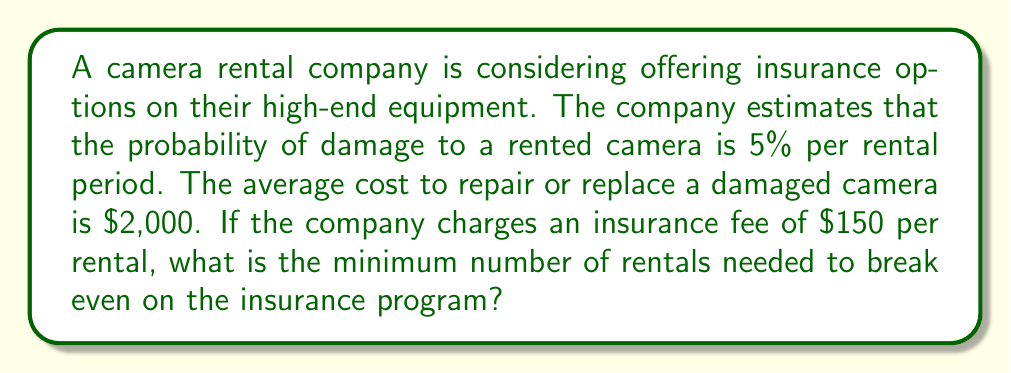Give your solution to this math problem. To solve this problem, we need to find the break-even point where the total revenue from insurance fees equals the expected cost of repairs. Let's approach this step-by-step:

1. Define variables:
   Let $n$ be the number of rentals
   Let $p$ be the probability of damage (5% = 0.05)
   Let $c$ be the cost of repair ($2,000)
   Let $f$ be the insurance fee ($150)

2. Calculate expected cost:
   The expected number of damaged cameras is $n \cdot p$
   Expected cost = $n \cdot p \cdot c = n \cdot 0.05 \cdot 2000 = 100n$

3. Calculate revenue:
   Revenue from insurance fees = $n \cdot f = 150n$

4. Set up break-even equation:
   Revenue = Expected cost
   $150n = 100n$

5. Solve for $n$:
   $150n - 100n = 0$
   $50n = 0$
   $n = 0$

However, since we can't have zero rentals, we need to find the smallest positive integer $n$ where revenue exceeds expected cost:

$150n > 100n$
$n > 0$

Therefore, the minimum number of rentals needed to break even is 1.

To verify:
With 1 rental:
Revenue = $150 \cdot 1 = 150$
Expected cost = $100 \cdot 1 = 100$

$150 > 100$, so the company starts profiting from the first rental.
Answer: The minimum number of rentals needed to break even on the insurance program is 1. 